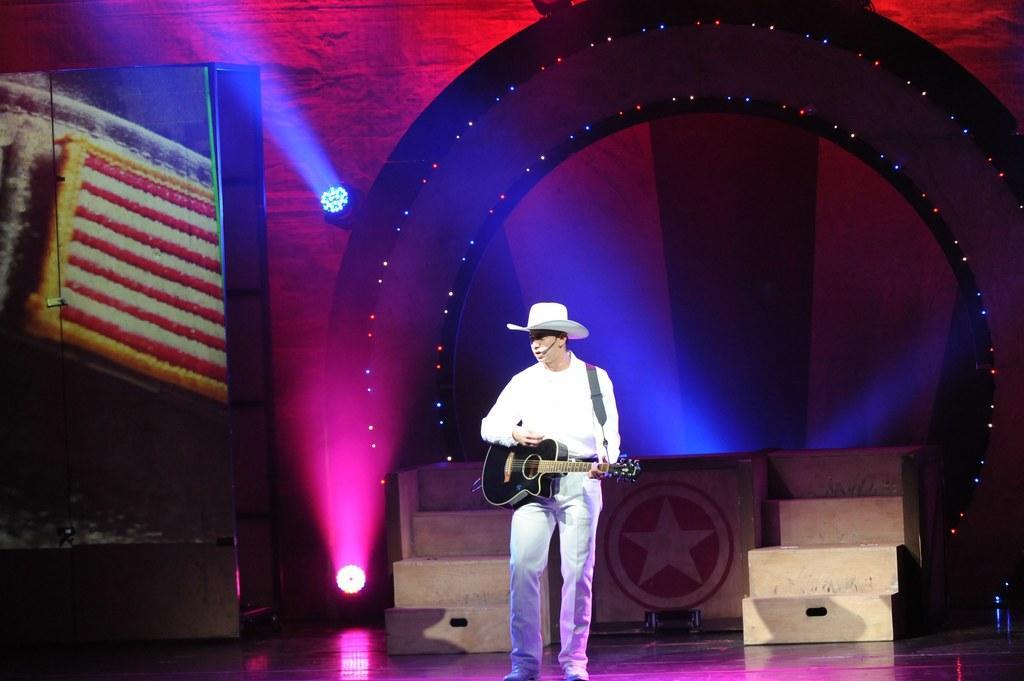Could you give a brief overview of what you see in this image? It is looking like a stage. Here I can see a man standing and playing the guitar. he is wearing white color shirt and cap on his head. In the background there are few lights. 